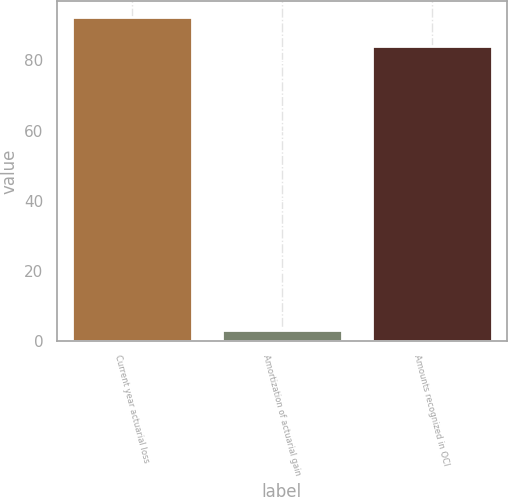Convert chart to OTSL. <chart><loc_0><loc_0><loc_500><loc_500><bar_chart><fcel>Current year actuarial loss<fcel>Amortization of actuarial gain<fcel>Amounts recognized in OCI<nl><fcel>92.4<fcel>3<fcel>84<nl></chart> 